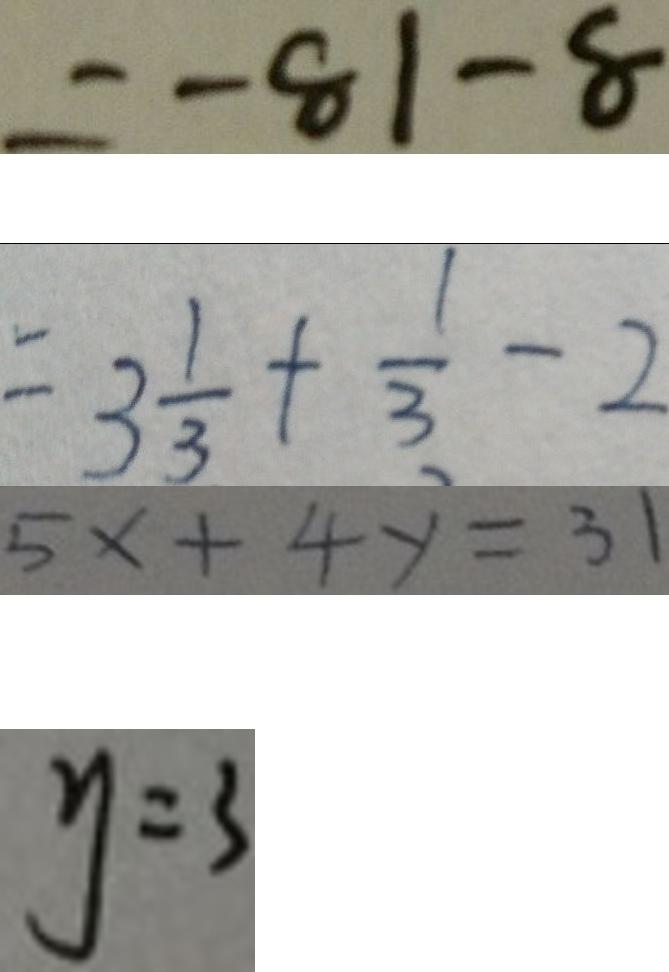Convert formula to latex. <formula><loc_0><loc_0><loc_500><loc_500>= - 8 1 - 8 
 = 3 \frac { 1 } { 3 } + \frac { 1 } { 3 } - 2 
 5 x + 4 y = 3 1 
 y = 3</formula> 